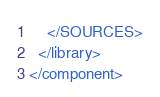Convert code to text. <code><loc_0><loc_0><loc_500><loc_500><_XML_>    </SOURCES>
  </library>
</component></code> 